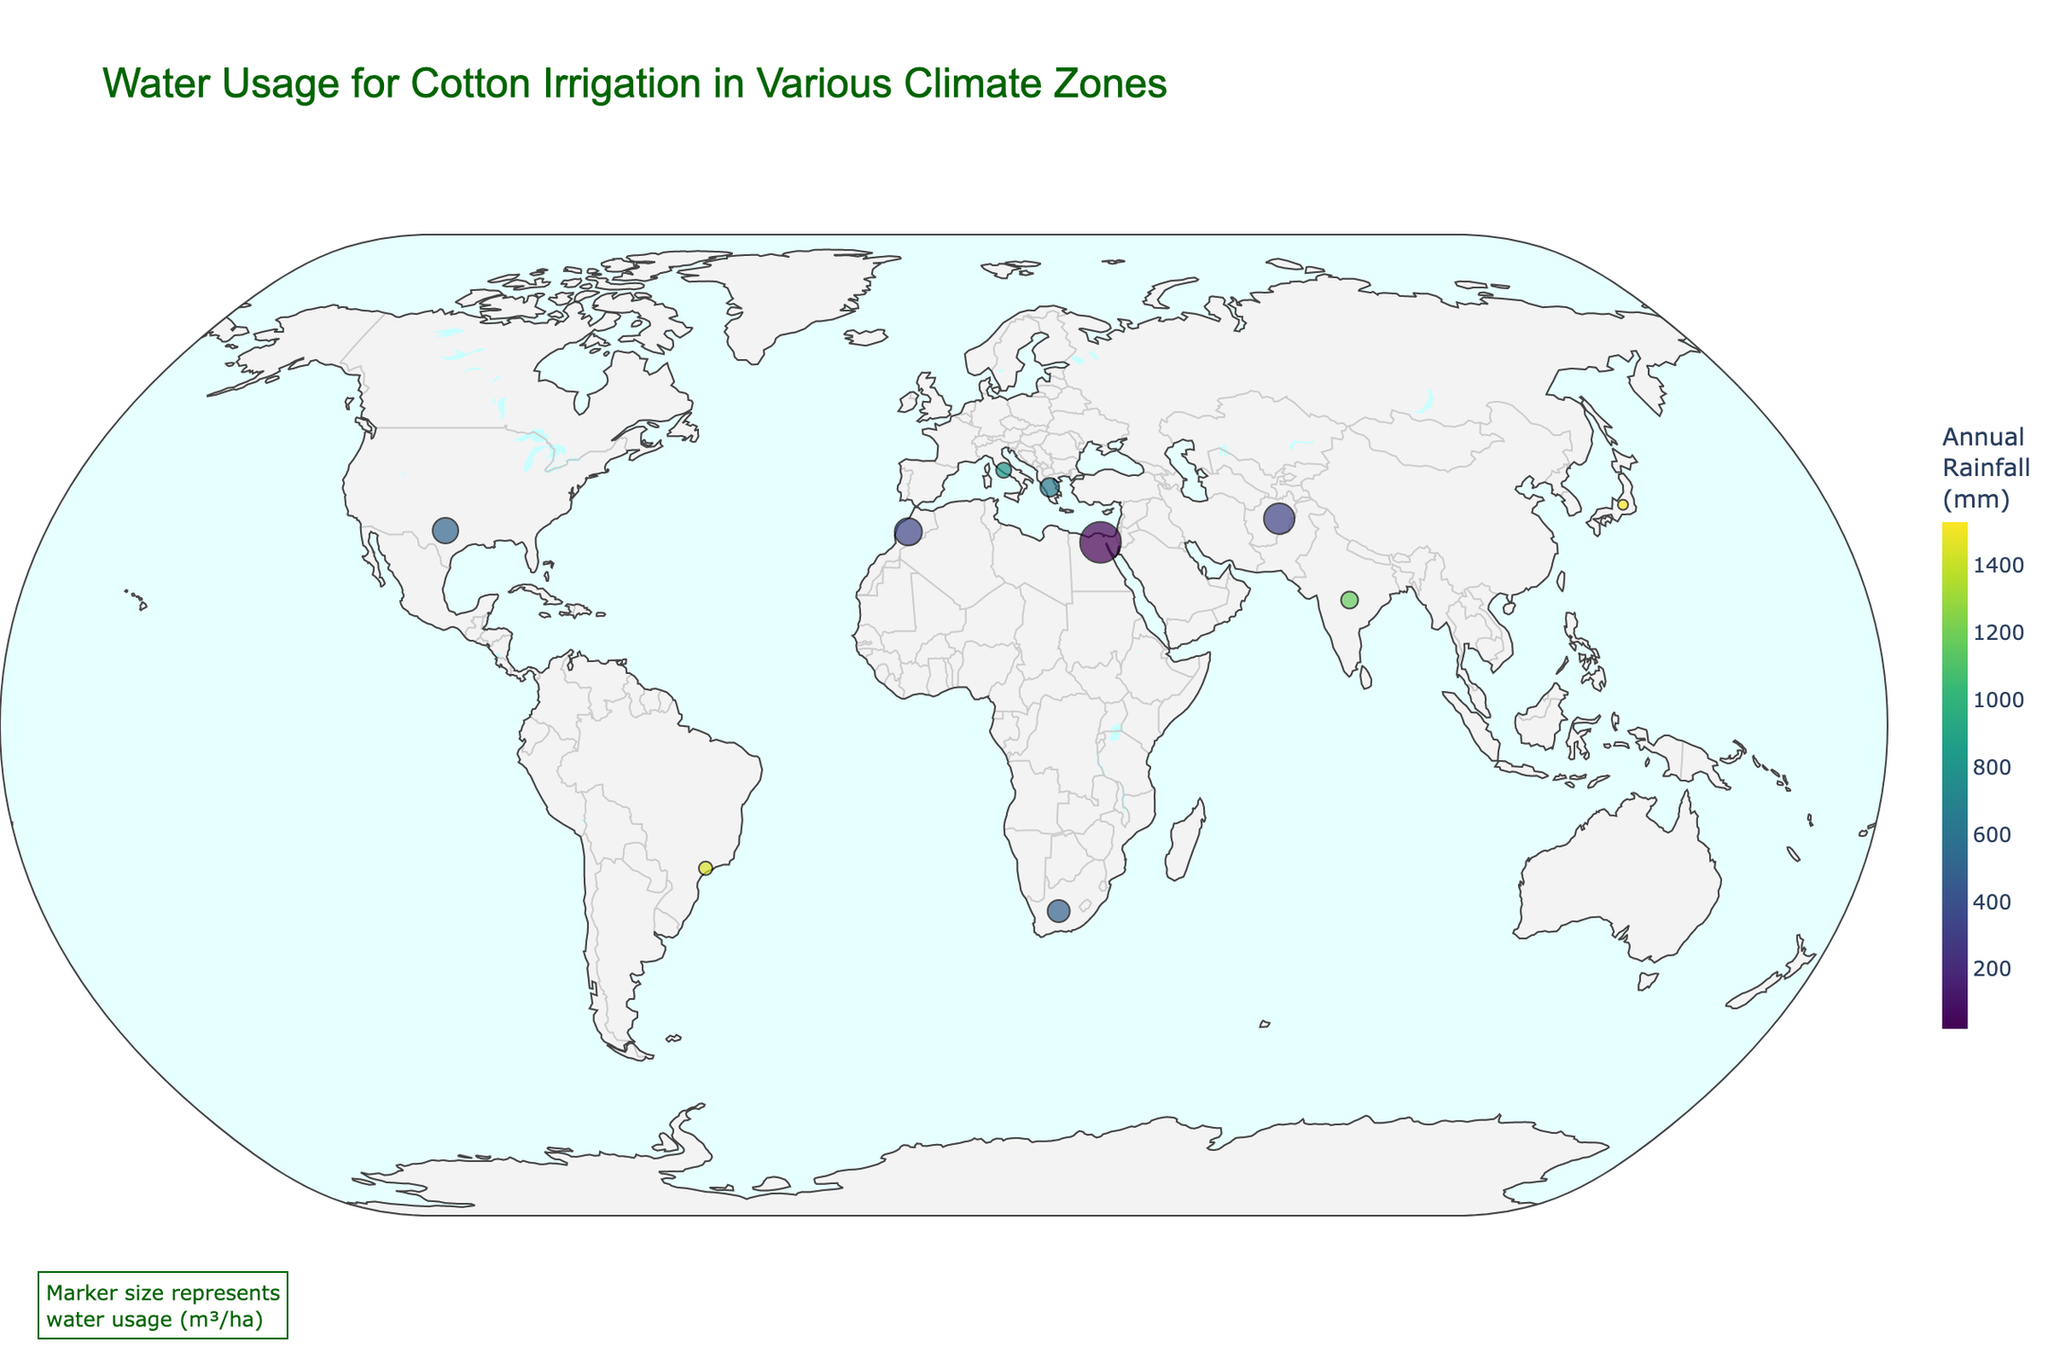What is the title of the figure? The title of the figure is located at the top and is centered. It provides a brief description of the data presented.
Answer: Water Usage for Cotton Irrigation in Various Climate Zones How many unique climate zones are displayed in the plot? By reviewing the legend and the labels in the figure, it's possible to count the number of unique climate zones listed.
Answer: 5 Which region uses the most water for cotton irrigation? Observing the marker sizes, the region with the largest marker corresponds to the highest water usage.
Answer: Egypt Which climate zone has the highest annual rainfall? The color scale provided indicates the amount of annual rainfall, where higher values are represented by a specific color shade. By observing the regions that match the highest shade, the climate zone can be identified.
Answer: Tropical (India and Brazil) What is the relationship between annual rainfall and water usage for cotton irrigation? By comparing the colors (which represent rainfall) and the marker sizes (which indicate water usage), one can infer any patterns or relationships.
Answer: Generally, regions with lower rainfall have higher water usage Which irrigation method is most common among regions with semi-arid climates? Review the data points labeled as Semi-arid in the figure and examine their irrigation methods listed in the labels.
Answer: Sprinkler (Texas) and Drip (Morocco) What region has the smallest water usage for cotton irrigation, and what irrigation method do they use? The smallest marker signifies the region with the least water usage. Check the size and label details to determine the region and the irrigation method used.
Answer: Japan; Sub-surface Drip Compare the water usage for cotton irrigation between Mediterranean and Tropical climate zones. Sum the water usage values for regions in each climate zone and then compare the totals. Mediterranean: South Africa (6500) + Italy (4500) + Greece (5500) = 16500 m³/ha; Tropical: India (5000) + Brazil (4000) = 9000 m³/ha
Answer: Mediterranean zones use more water in total Which region in Mediterranean climate zones has the highest annual rainfall? Observing the color scale for Mediterranean regions (South Africa, Italy, Greece) and identifying the one with the shade indicating the highest rainfall.
Answer: Italy What latitude and longitude correspond to the region with the highest water usage? Check the coordinates of the region indicated by the largest marker for water usage.
Answer: Latitude: 30.0444, Longitude: 31.2357 (Egypt) 